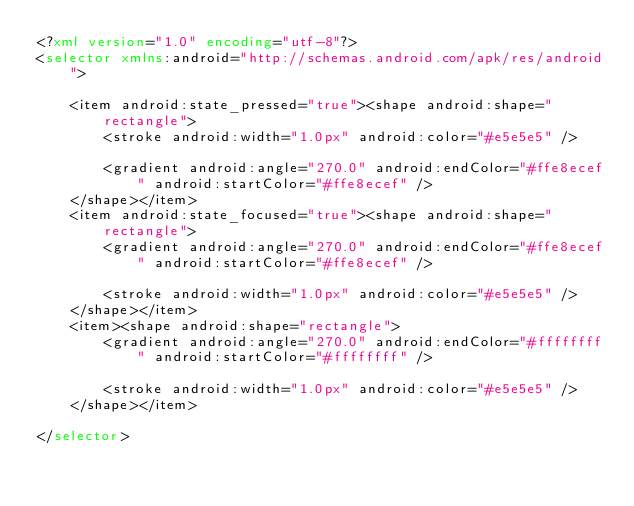Convert code to text. <code><loc_0><loc_0><loc_500><loc_500><_XML_><?xml version="1.0" encoding="utf-8"?>
<selector xmlns:android="http://schemas.android.com/apk/res/android">

    <item android:state_pressed="true"><shape android:shape="rectangle">
        <stroke android:width="1.0px" android:color="#e5e5e5" />

        <gradient android:angle="270.0" android:endColor="#ffe8ecef" android:startColor="#ffe8ecef" />
    </shape></item>
    <item android:state_focused="true"><shape android:shape="rectangle">
        <gradient android:angle="270.0" android:endColor="#ffe8ecef" android:startColor="#ffe8ecef" />

        <stroke android:width="1.0px" android:color="#e5e5e5" />
    </shape></item>
    <item><shape android:shape="rectangle">
        <gradient android:angle="270.0" android:endColor="#ffffffff" android:startColor="#ffffffff" />

        <stroke android:width="1.0px" android:color="#e5e5e5" />
    </shape></item>

</selector></code> 